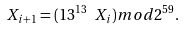<formula> <loc_0><loc_0><loc_500><loc_500>X _ { i + 1 } = ( 1 3 ^ { 1 3 } \ X _ { i } ) m o d 2 ^ { 5 9 } .</formula> 